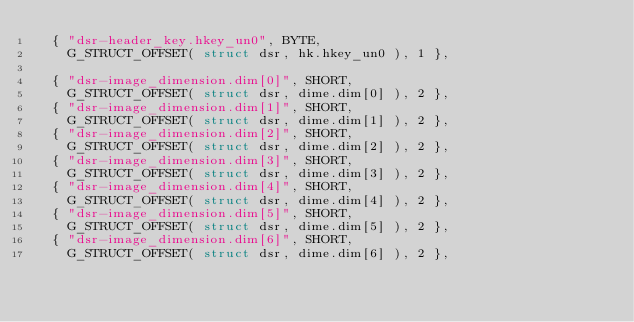Convert code to text. <code><loc_0><loc_0><loc_500><loc_500><_C_>	{ "dsr-header_key.hkey_un0", BYTE, 
		G_STRUCT_OFFSET( struct dsr, hk.hkey_un0 ), 1 },

	{ "dsr-image_dimension.dim[0]", SHORT, 
		G_STRUCT_OFFSET( struct dsr, dime.dim[0] ), 2 },
	{ "dsr-image_dimension.dim[1]", SHORT, 
		G_STRUCT_OFFSET( struct dsr, dime.dim[1] ), 2 },
	{ "dsr-image_dimension.dim[2]", SHORT, 
		G_STRUCT_OFFSET( struct dsr, dime.dim[2] ), 2 },
	{ "dsr-image_dimension.dim[3]", SHORT, 
		G_STRUCT_OFFSET( struct dsr, dime.dim[3] ), 2 },
	{ "dsr-image_dimension.dim[4]", SHORT, 
		G_STRUCT_OFFSET( struct dsr, dime.dim[4] ), 2 },
	{ "dsr-image_dimension.dim[5]", SHORT, 
		G_STRUCT_OFFSET( struct dsr, dime.dim[5] ), 2 },
	{ "dsr-image_dimension.dim[6]", SHORT, 
		G_STRUCT_OFFSET( struct dsr, dime.dim[6] ), 2 },</code> 